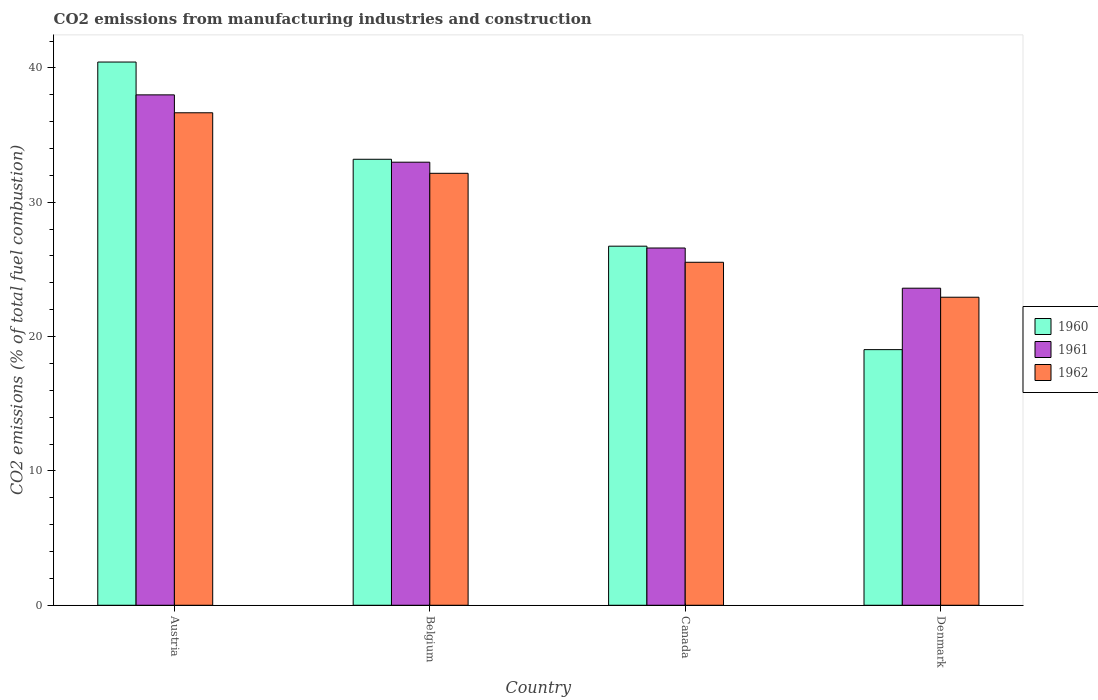How many different coloured bars are there?
Ensure brevity in your answer.  3. How many groups of bars are there?
Ensure brevity in your answer.  4. How many bars are there on the 4th tick from the left?
Your answer should be very brief. 3. What is the label of the 2nd group of bars from the left?
Offer a very short reply. Belgium. What is the amount of CO2 emitted in 1960 in Denmark?
Your answer should be very brief. 19.03. Across all countries, what is the maximum amount of CO2 emitted in 1961?
Ensure brevity in your answer.  37.99. Across all countries, what is the minimum amount of CO2 emitted in 1961?
Give a very brief answer. 23.6. In which country was the amount of CO2 emitted in 1961 minimum?
Your answer should be compact. Denmark. What is the total amount of CO2 emitted in 1962 in the graph?
Provide a short and direct response. 117.28. What is the difference between the amount of CO2 emitted in 1961 in Canada and that in Denmark?
Give a very brief answer. 2.99. What is the difference between the amount of CO2 emitted in 1961 in Austria and the amount of CO2 emitted in 1960 in Belgium?
Provide a short and direct response. 4.79. What is the average amount of CO2 emitted in 1961 per country?
Offer a terse response. 30.29. What is the difference between the amount of CO2 emitted of/in 1960 and amount of CO2 emitted of/in 1961 in Austria?
Make the answer very short. 2.44. What is the ratio of the amount of CO2 emitted in 1960 in Austria to that in Denmark?
Provide a succinct answer. 2.13. What is the difference between the highest and the second highest amount of CO2 emitted in 1961?
Your answer should be compact. 6.39. What is the difference between the highest and the lowest amount of CO2 emitted in 1960?
Your answer should be very brief. 21.41. What does the 3rd bar from the right in Belgium represents?
Your answer should be compact. 1960. What is the difference between two consecutive major ticks on the Y-axis?
Your answer should be compact. 10. Does the graph contain any zero values?
Your answer should be very brief. No. How are the legend labels stacked?
Make the answer very short. Vertical. What is the title of the graph?
Your response must be concise. CO2 emissions from manufacturing industries and construction. Does "2010" appear as one of the legend labels in the graph?
Your answer should be compact. No. What is the label or title of the X-axis?
Offer a very short reply. Country. What is the label or title of the Y-axis?
Your answer should be very brief. CO2 emissions (% of total fuel combustion). What is the CO2 emissions (% of total fuel combustion) in 1960 in Austria?
Make the answer very short. 40.44. What is the CO2 emissions (% of total fuel combustion) in 1961 in Austria?
Offer a terse response. 37.99. What is the CO2 emissions (% of total fuel combustion) in 1962 in Austria?
Provide a succinct answer. 36.66. What is the CO2 emissions (% of total fuel combustion) of 1960 in Belgium?
Your response must be concise. 33.2. What is the CO2 emissions (% of total fuel combustion) in 1961 in Belgium?
Your answer should be very brief. 32.98. What is the CO2 emissions (% of total fuel combustion) in 1962 in Belgium?
Your answer should be compact. 32.16. What is the CO2 emissions (% of total fuel combustion) of 1960 in Canada?
Provide a short and direct response. 26.73. What is the CO2 emissions (% of total fuel combustion) of 1961 in Canada?
Offer a terse response. 26.59. What is the CO2 emissions (% of total fuel combustion) of 1962 in Canada?
Provide a short and direct response. 25.53. What is the CO2 emissions (% of total fuel combustion) in 1960 in Denmark?
Ensure brevity in your answer.  19.03. What is the CO2 emissions (% of total fuel combustion) in 1961 in Denmark?
Ensure brevity in your answer.  23.6. What is the CO2 emissions (% of total fuel combustion) of 1962 in Denmark?
Offer a terse response. 22.93. Across all countries, what is the maximum CO2 emissions (% of total fuel combustion) in 1960?
Offer a terse response. 40.44. Across all countries, what is the maximum CO2 emissions (% of total fuel combustion) of 1961?
Provide a succinct answer. 37.99. Across all countries, what is the maximum CO2 emissions (% of total fuel combustion) in 1962?
Keep it short and to the point. 36.66. Across all countries, what is the minimum CO2 emissions (% of total fuel combustion) in 1960?
Your answer should be compact. 19.03. Across all countries, what is the minimum CO2 emissions (% of total fuel combustion) of 1961?
Make the answer very short. 23.6. Across all countries, what is the minimum CO2 emissions (% of total fuel combustion) in 1962?
Offer a terse response. 22.93. What is the total CO2 emissions (% of total fuel combustion) of 1960 in the graph?
Your answer should be very brief. 119.4. What is the total CO2 emissions (% of total fuel combustion) of 1961 in the graph?
Ensure brevity in your answer.  121.18. What is the total CO2 emissions (% of total fuel combustion) of 1962 in the graph?
Ensure brevity in your answer.  117.28. What is the difference between the CO2 emissions (% of total fuel combustion) in 1960 in Austria and that in Belgium?
Ensure brevity in your answer.  7.24. What is the difference between the CO2 emissions (% of total fuel combustion) of 1961 in Austria and that in Belgium?
Your response must be concise. 5.01. What is the difference between the CO2 emissions (% of total fuel combustion) in 1962 in Austria and that in Belgium?
Make the answer very short. 4.51. What is the difference between the CO2 emissions (% of total fuel combustion) of 1960 in Austria and that in Canada?
Give a very brief answer. 13.71. What is the difference between the CO2 emissions (% of total fuel combustion) of 1961 in Austria and that in Canada?
Provide a short and direct response. 11.4. What is the difference between the CO2 emissions (% of total fuel combustion) in 1962 in Austria and that in Canada?
Offer a very short reply. 11.13. What is the difference between the CO2 emissions (% of total fuel combustion) of 1960 in Austria and that in Denmark?
Your answer should be very brief. 21.41. What is the difference between the CO2 emissions (% of total fuel combustion) of 1961 in Austria and that in Denmark?
Give a very brief answer. 14.39. What is the difference between the CO2 emissions (% of total fuel combustion) in 1962 in Austria and that in Denmark?
Provide a short and direct response. 13.73. What is the difference between the CO2 emissions (% of total fuel combustion) of 1960 in Belgium and that in Canada?
Your answer should be very brief. 6.47. What is the difference between the CO2 emissions (% of total fuel combustion) in 1961 in Belgium and that in Canada?
Keep it short and to the point. 6.39. What is the difference between the CO2 emissions (% of total fuel combustion) in 1962 in Belgium and that in Canada?
Offer a terse response. 6.62. What is the difference between the CO2 emissions (% of total fuel combustion) of 1960 in Belgium and that in Denmark?
Offer a very short reply. 14.17. What is the difference between the CO2 emissions (% of total fuel combustion) in 1961 in Belgium and that in Denmark?
Provide a succinct answer. 9.38. What is the difference between the CO2 emissions (% of total fuel combustion) in 1962 in Belgium and that in Denmark?
Your response must be concise. 9.23. What is the difference between the CO2 emissions (% of total fuel combustion) of 1960 in Canada and that in Denmark?
Your response must be concise. 7.7. What is the difference between the CO2 emissions (% of total fuel combustion) of 1961 in Canada and that in Denmark?
Offer a terse response. 2.99. What is the difference between the CO2 emissions (% of total fuel combustion) of 1962 in Canada and that in Denmark?
Keep it short and to the point. 2.6. What is the difference between the CO2 emissions (% of total fuel combustion) in 1960 in Austria and the CO2 emissions (% of total fuel combustion) in 1961 in Belgium?
Give a very brief answer. 7.46. What is the difference between the CO2 emissions (% of total fuel combustion) in 1960 in Austria and the CO2 emissions (% of total fuel combustion) in 1962 in Belgium?
Your answer should be compact. 8.28. What is the difference between the CO2 emissions (% of total fuel combustion) in 1961 in Austria and the CO2 emissions (% of total fuel combustion) in 1962 in Belgium?
Your answer should be very brief. 5.84. What is the difference between the CO2 emissions (% of total fuel combustion) in 1960 in Austria and the CO2 emissions (% of total fuel combustion) in 1961 in Canada?
Keep it short and to the point. 13.84. What is the difference between the CO2 emissions (% of total fuel combustion) in 1960 in Austria and the CO2 emissions (% of total fuel combustion) in 1962 in Canada?
Ensure brevity in your answer.  14.91. What is the difference between the CO2 emissions (% of total fuel combustion) in 1961 in Austria and the CO2 emissions (% of total fuel combustion) in 1962 in Canada?
Make the answer very short. 12.46. What is the difference between the CO2 emissions (% of total fuel combustion) in 1960 in Austria and the CO2 emissions (% of total fuel combustion) in 1961 in Denmark?
Your answer should be very brief. 16.84. What is the difference between the CO2 emissions (% of total fuel combustion) in 1960 in Austria and the CO2 emissions (% of total fuel combustion) in 1962 in Denmark?
Make the answer very short. 17.51. What is the difference between the CO2 emissions (% of total fuel combustion) of 1961 in Austria and the CO2 emissions (% of total fuel combustion) of 1962 in Denmark?
Give a very brief answer. 15.06. What is the difference between the CO2 emissions (% of total fuel combustion) of 1960 in Belgium and the CO2 emissions (% of total fuel combustion) of 1961 in Canada?
Offer a very short reply. 6.61. What is the difference between the CO2 emissions (% of total fuel combustion) in 1960 in Belgium and the CO2 emissions (% of total fuel combustion) in 1962 in Canada?
Provide a succinct answer. 7.67. What is the difference between the CO2 emissions (% of total fuel combustion) of 1961 in Belgium and the CO2 emissions (% of total fuel combustion) of 1962 in Canada?
Give a very brief answer. 7.45. What is the difference between the CO2 emissions (% of total fuel combustion) of 1960 in Belgium and the CO2 emissions (% of total fuel combustion) of 1961 in Denmark?
Make the answer very short. 9.6. What is the difference between the CO2 emissions (% of total fuel combustion) in 1960 in Belgium and the CO2 emissions (% of total fuel combustion) in 1962 in Denmark?
Give a very brief answer. 10.27. What is the difference between the CO2 emissions (% of total fuel combustion) in 1961 in Belgium and the CO2 emissions (% of total fuel combustion) in 1962 in Denmark?
Provide a short and direct response. 10.05. What is the difference between the CO2 emissions (% of total fuel combustion) in 1960 in Canada and the CO2 emissions (% of total fuel combustion) in 1961 in Denmark?
Provide a succinct answer. 3.13. What is the difference between the CO2 emissions (% of total fuel combustion) in 1960 in Canada and the CO2 emissions (% of total fuel combustion) in 1962 in Denmark?
Your answer should be compact. 3.8. What is the difference between the CO2 emissions (% of total fuel combustion) of 1961 in Canada and the CO2 emissions (% of total fuel combustion) of 1962 in Denmark?
Your response must be concise. 3.66. What is the average CO2 emissions (% of total fuel combustion) of 1960 per country?
Offer a very short reply. 29.85. What is the average CO2 emissions (% of total fuel combustion) in 1961 per country?
Ensure brevity in your answer.  30.29. What is the average CO2 emissions (% of total fuel combustion) of 1962 per country?
Make the answer very short. 29.32. What is the difference between the CO2 emissions (% of total fuel combustion) in 1960 and CO2 emissions (% of total fuel combustion) in 1961 in Austria?
Keep it short and to the point. 2.44. What is the difference between the CO2 emissions (% of total fuel combustion) of 1960 and CO2 emissions (% of total fuel combustion) of 1962 in Austria?
Offer a terse response. 3.78. What is the difference between the CO2 emissions (% of total fuel combustion) in 1961 and CO2 emissions (% of total fuel combustion) in 1962 in Austria?
Ensure brevity in your answer.  1.33. What is the difference between the CO2 emissions (% of total fuel combustion) in 1960 and CO2 emissions (% of total fuel combustion) in 1961 in Belgium?
Ensure brevity in your answer.  0.22. What is the difference between the CO2 emissions (% of total fuel combustion) of 1960 and CO2 emissions (% of total fuel combustion) of 1962 in Belgium?
Your answer should be very brief. 1.04. What is the difference between the CO2 emissions (% of total fuel combustion) in 1961 and CO2 emissions (% of total fuel combustion) in 1962 in Belgium?
Your answer should be compact. 0.83. What is the difference between the CO2 emissions (% of total fuel combustion) of 1960 and CO2 emissions (% of total fuel combustion) of 1961 in Canada?
Give a very brief answer. 0.14. What is the difference between the CO2 emissions (% of total fuel combustion) in 1960 and CO2 emissions (% of total fuel combustion) in 1962 in Canada?
Your response must be concise. 1.2. What is the difference between the CO2 emissions (% of total fuel combustion) in 1961 and CO2 emissions (% of total fuel combustion) in 1962 in Canada?
Your answer should be very brief. 1.06. What is the difference between the CO2 emissions (% of total fuel combustion) of 1960 and CO2 emissions (% of total fuel combustion) of 1961 in Denmark?
Your answer should be compact. -4.57. What is the difference between the CO2 emissions (% of total fuel combustion) of 1960 and CO2 emissions (% of total fuel combustion) of 1962 in Denmark?
Provide a short and direct response. -3.9. What is the difference between the CO2 emissions (% of total fuel combustion) in 1961 and CO2 emissions (% of total fuel combustion) in 1962 in Denmark?
Provide a succinct answer. 0.67. What is the ratio of the CO2 emissions (% of total fuel combustion) in 1960 in Austria to that in Belgium?
Make the answer very short. 1.22. What is the ratio of the CO2 emissions (% of total fuel combustion) of 1961 in Austria to that in Belgium?
Your answer should be compact. 1.15. What is the ratio of the CO2 emissions (% of total fuel combustion) of 1962 in Austria to that in Belgium?
Keep it short and to the point. 1.14. What is the ratio of the CO2 emissions (% of total fuel combustion) in 1960 in Austria to that in Canada?
Provide a short and direct response. 1.51. What is the ratio of the CO2 emissions (% of total fuel combustion) of 1961 in Austria to that in Canada?
Your answer should be very brief. 1.43. What is the ratio of the CO2 emissions (% of total fuel combustion) of 1962 in Austria to that in Canada?
Your answer should be compact. 1.44. What is the ratio of the CO2 emissions (% of total fuel combustion) of 1960 in Austria to that in Denmark?
Provide a succinct answer. 2.13. What is the ratio of the CO2 emissions (% of total fuel combustion) of 1961 in Austria to that in Denmark?
Ensure brevity in your answer.  1.61. What is the ratio of the CO2 emissions (% of total fuel combustion) in 1962 in Austria to that in Denmark?
Ensure brevity in your answer.  1.6. What is the ratio of the CO2 emissions (% of total fuel combustion) of 1960 in Belgium to that in Canada?
Make the answer very short. 1.24. What is the ratio of the CO2 emissions (% of total fuel combustion) in 1961 in Belgium to that in Canada?
Give a very brief answer. 1.24. What is the ratio of the CO2 emissions (% of total fuel combustion) in 1962 in Belgium to that in Canada?
Provide a succinct answer. 1.26. What is the ratio of the CO2 emissions (% of total fuel combustion) of 1960 in Belgium to that in Denmark?
Offer a terse response. 1.74. What is the ratio of the CO2 emissions (% of total fuel combustion) in 1961 in Belgium to that in Denmark?
Ensure brevity in your answer.  1.4. What is the ratio of the CO2 emissions (% of total fuel combustion) of 1962 in Belgium to that in Denmark?
Make the answer very short. 1.4. What is the ratio of the CO2 emissions (% of total fuel combustion) in 1960 in Canada to that in Denmark?
Your answer should be compact. 1.4. What is the ratio of the CO2 emissions (% of total fuel combustion) of 1961 in Canada to that in Denmark?
Keep it short and to the point. 1.13. What is the ratio of the CO2 emissions (% of total fuel combustion) in 1962 in Canada to that in Denmark?
Make the answer very short. 1.11. What is the difference between the highest and the second highest CO2 emissions (% of total fuel combustion) of 1960?
Offer a terse response. 7.24. What is the difference between the highest and the second highest CO2 emissions (% of total fuel combustion) of 1961?
Provide a short and direct response. 5.01. What is the difference between the highest and the second highest CO2 emissions (% of total fuel combustion) in 1962?
Provide a short and direct response. 4.51. What is the difference between the highest and the lowest CO2 emissions (% of total fuel combustion) of 1960?
Give a very brief answer. 21.41. What is the difference between the highest and the lowest CO2 emissions (% of total fuel combustion) of 1961?
Your response must be concise. 14.39. What is the difference between the highest and the lowest CO2 emissions (% of total fuel combustion) in 1962?
Provide a succinct answer. 13.73. 